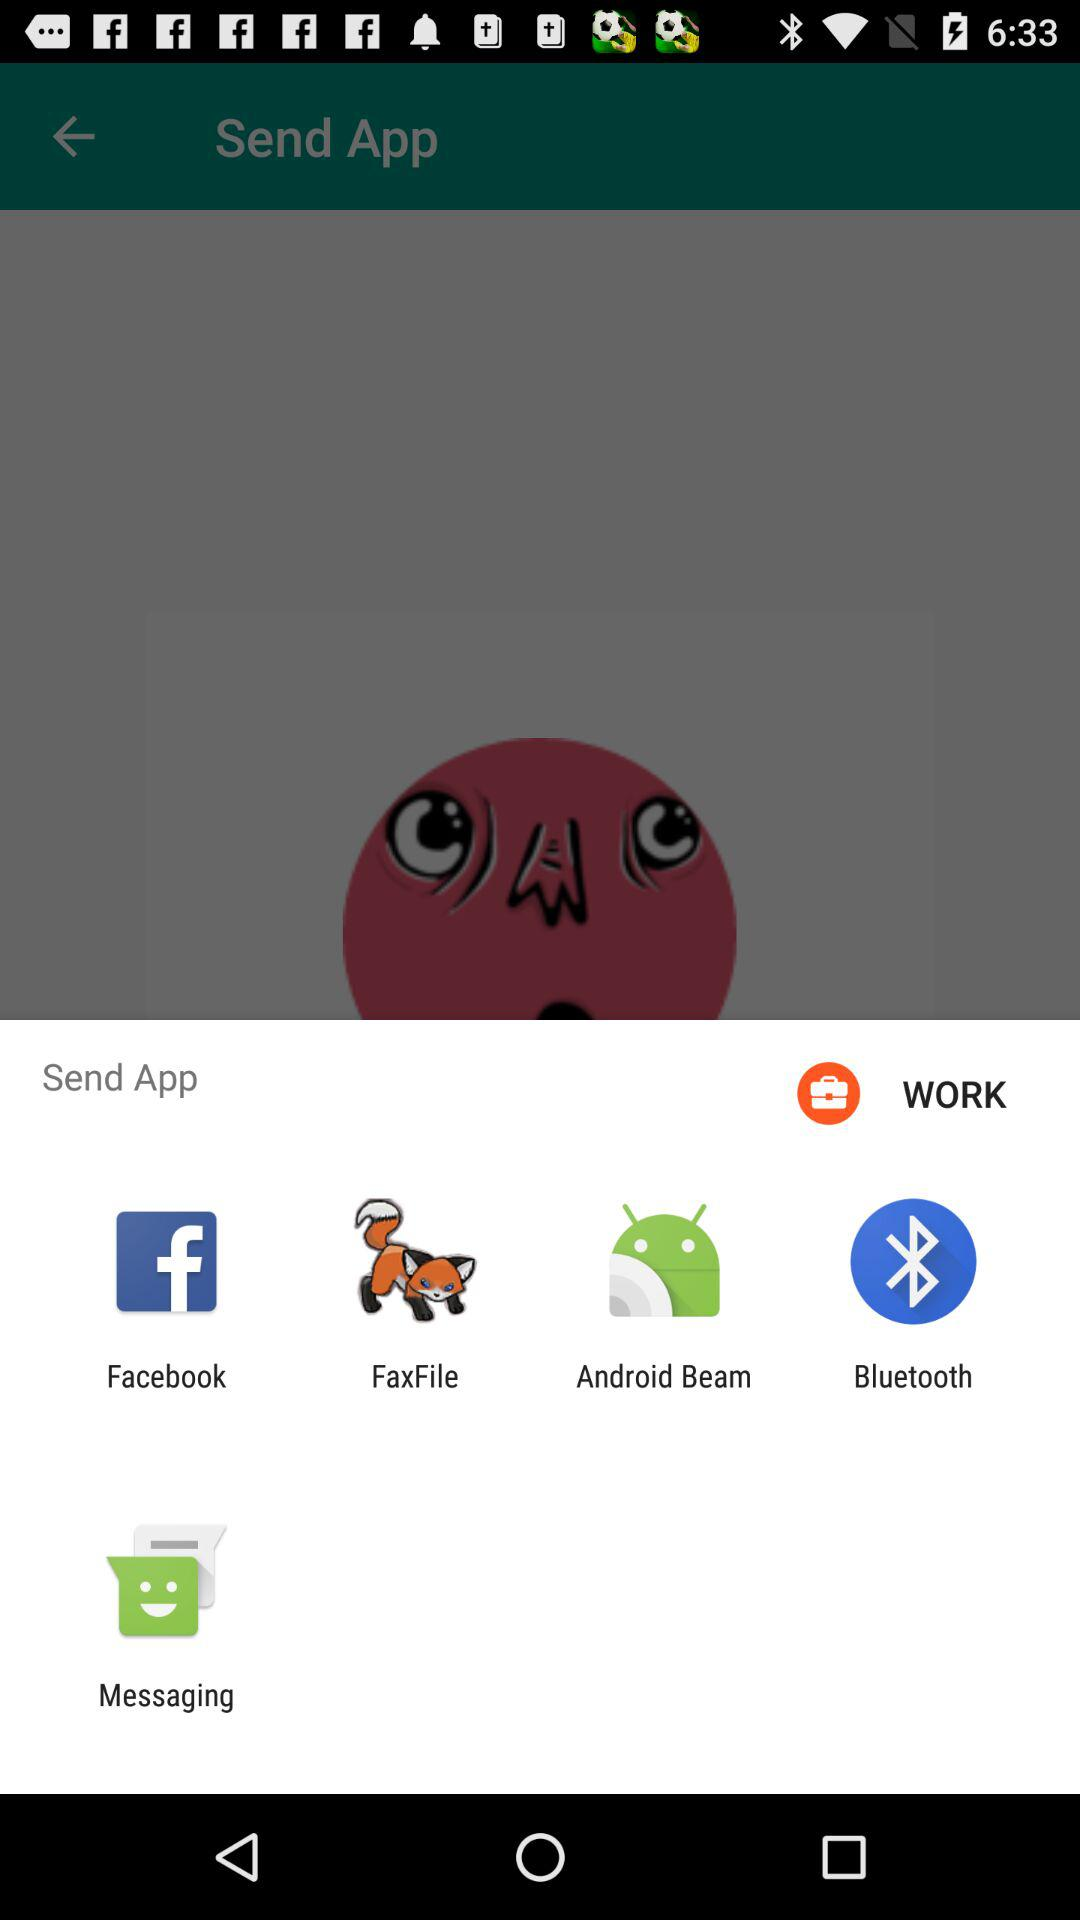How many items have a text label?
Answer the question using a single word or phrase. 5 